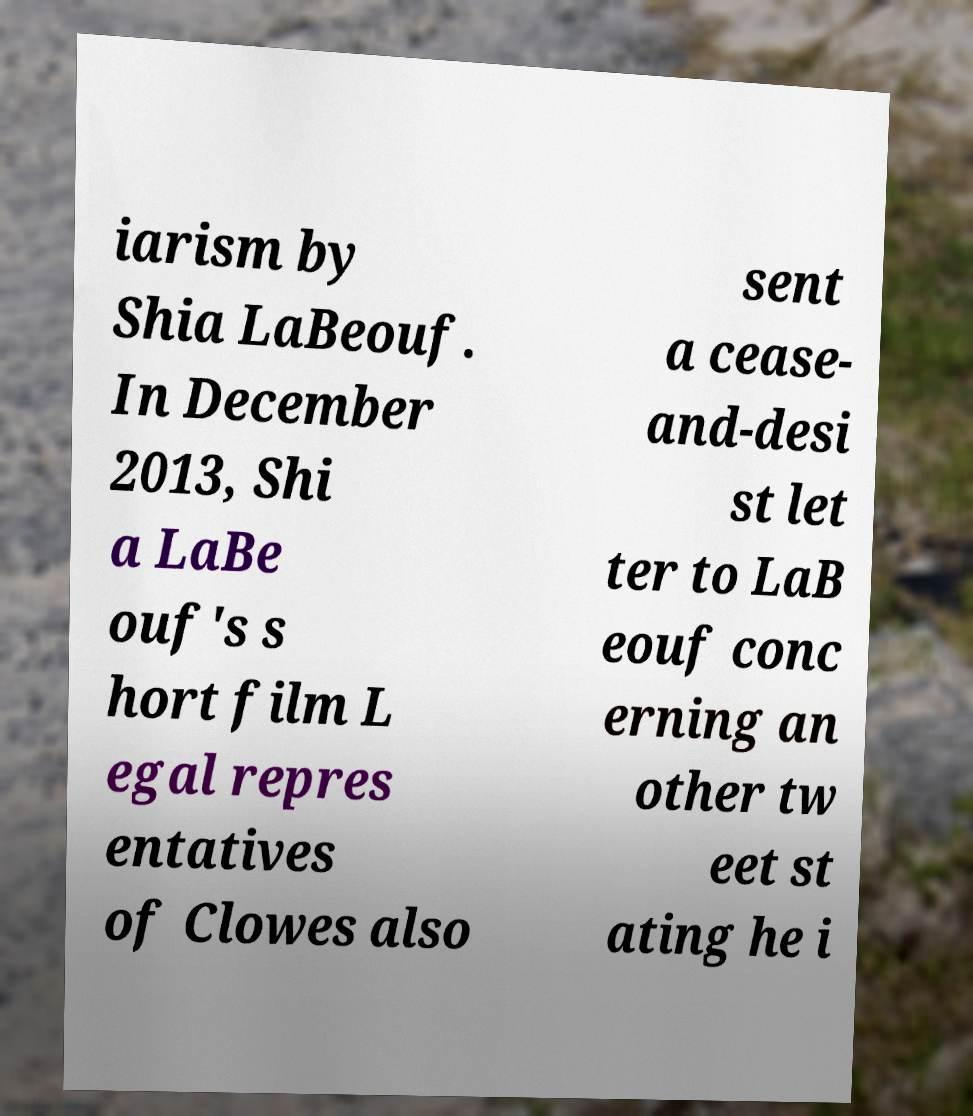What messages or text are displayed in this image? I need them in a readable, typed format. iarism by Shia LaBeouf. In December 2013, Shi a LaBe ouf's s hort film L egal repres entatives of Clowes also sent a cease- and-desi st let ter to LaB eouf conc erning an other tw eet st ating he i 